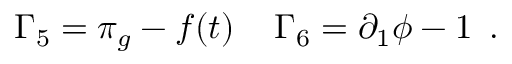<formula> <loc_0><loc_0><loc_500><loc_500>\Gamma _ { 5 } = \pi _ { g } - f ( t ) \, \Gamma _ { 6 } = \partial _ { 1 } \phi - 1 \, .</formula> 